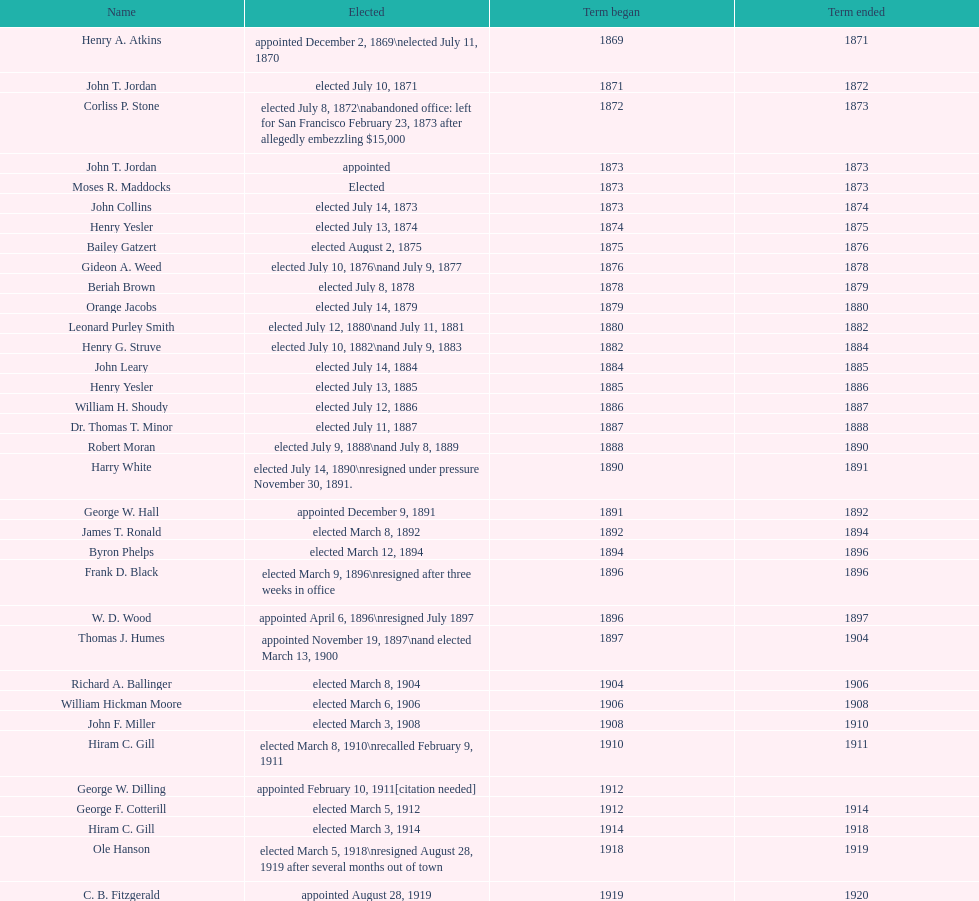Who was the first mayor in the 1900's? Richard A. Ballinger. 